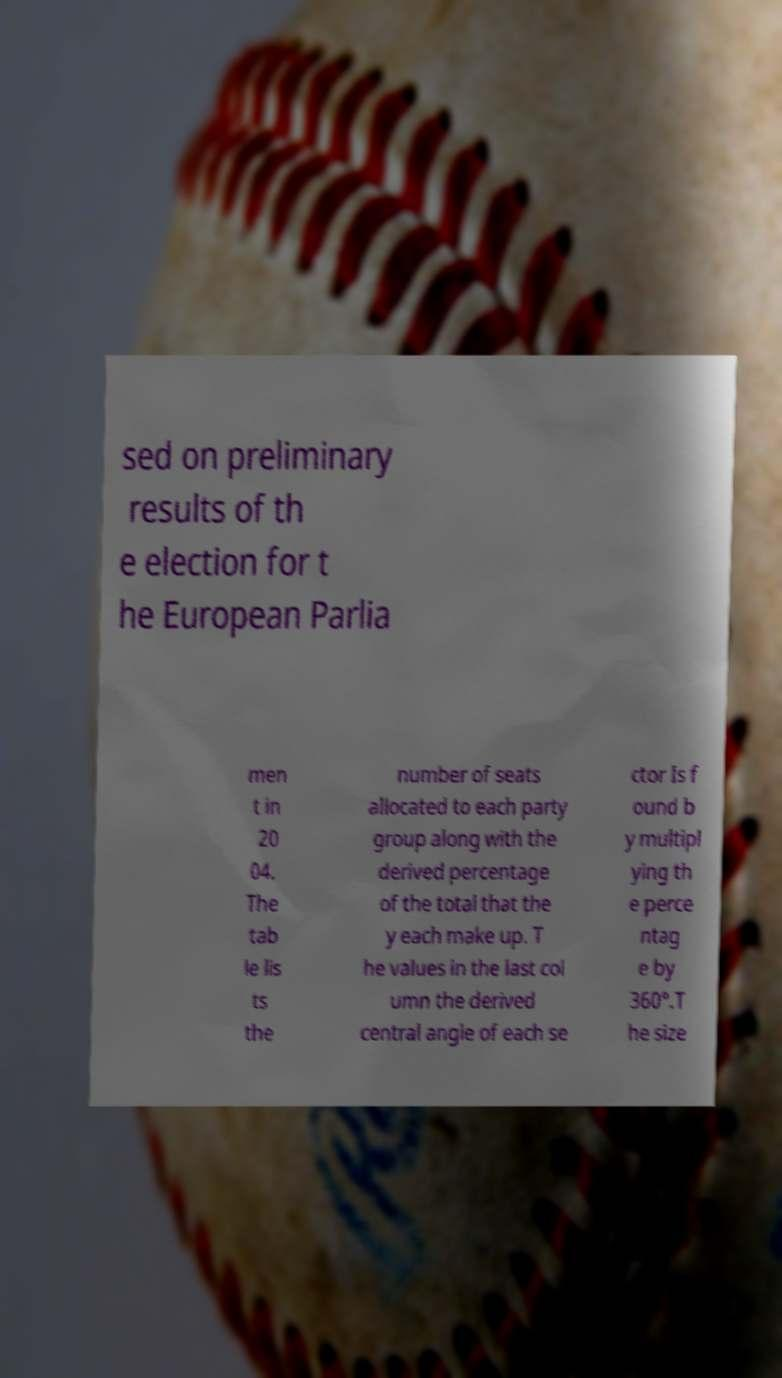What messages or text are displayed in this image? I need them in a readable, typed format. sed on preliminary results of th e election for t he European Parlia men t in 20 04. The tab le lis ts the number of seats allocated to each party group along with the derived percentage of the total that the y each make up. T he values in the last col umn the derived central angle of each se ctor Is f ound b y multipl ying th e perce ntag e by 360°.T he size 